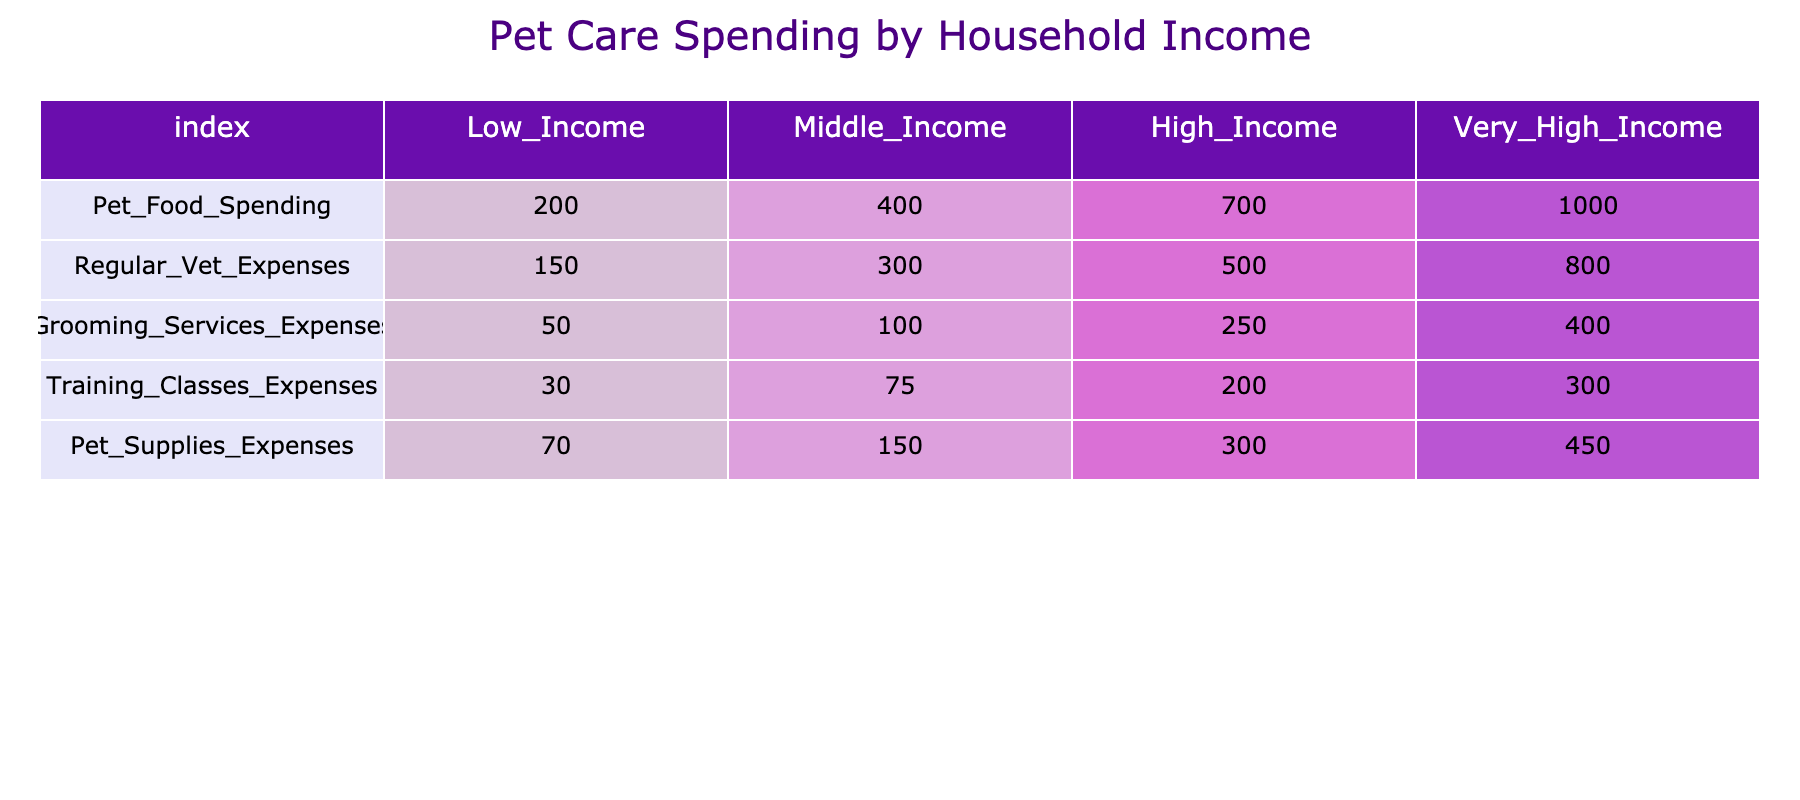What is the total spending on pet food for high-income households? From the table, the spending on pet food for high-income households is 700.
Answer: 700 How much more do very high-income households spend on pet supplies compared to low-income households? For very high-income households, pet supplies expenses are 450 and for low-income households, it is 70. Calculating the difference: 450 - 70 = 380.
Answer: 380 Is the total spending on regular vet expenses higher for middle-income households than for low-income households? The regular vet expenses for middle-income households are 300, while for low-income households, they are 150. 300 is greater than 150, therefore yes, middle-income households spend more.
Answer: Yes What is the average spending on grooming services across all income categories? Adding the grooming expenses: 50 + 100 + 250 + 400 = 800. Now, dividing by the number of income categories (4): 800 / 4 = 200.
Answer: 200 Which income category spends the least on training classes? Looking at the training classes expenses: low-income households spend 30, middle-income 75, high-income 200, and very high-income 300. The smallest value is 30 from low-income.
Answer: Low_income How much do high-income households spend in total on all pet care spending categories? Summing all expenses for high-income: Pet Food 700 + Regular Vet 500 + Grooming Services 250 + Training Classes 200 + Pet Supplies 300 = 1950.
Answer: 1950 Do low-income households spend more on pet food or on grooming services? Low-income households spend 200 on pet food and 50 on grooming services. Since 200 is greater than 50, low-income households spend more on pet food.
Answer: Pet food If you combine the spending on regular vet expenses for low-income and middle-income households, what is the total? The regular vet expenses are 150 for low-income and 300 for middle-income. Adding them together: 150 + 300 = 450.
Answer: 450 What percentage of total spending on pet supplies do very high-income households represent compared to low-income households? Very high-income households spend 450 and low-income households spend 70. The total for both is 450 + 70 = 520. Calculating the percentage for very high-income: (450 / 520) * 100 ≈ 86.54%.
Answer: 86.54% 